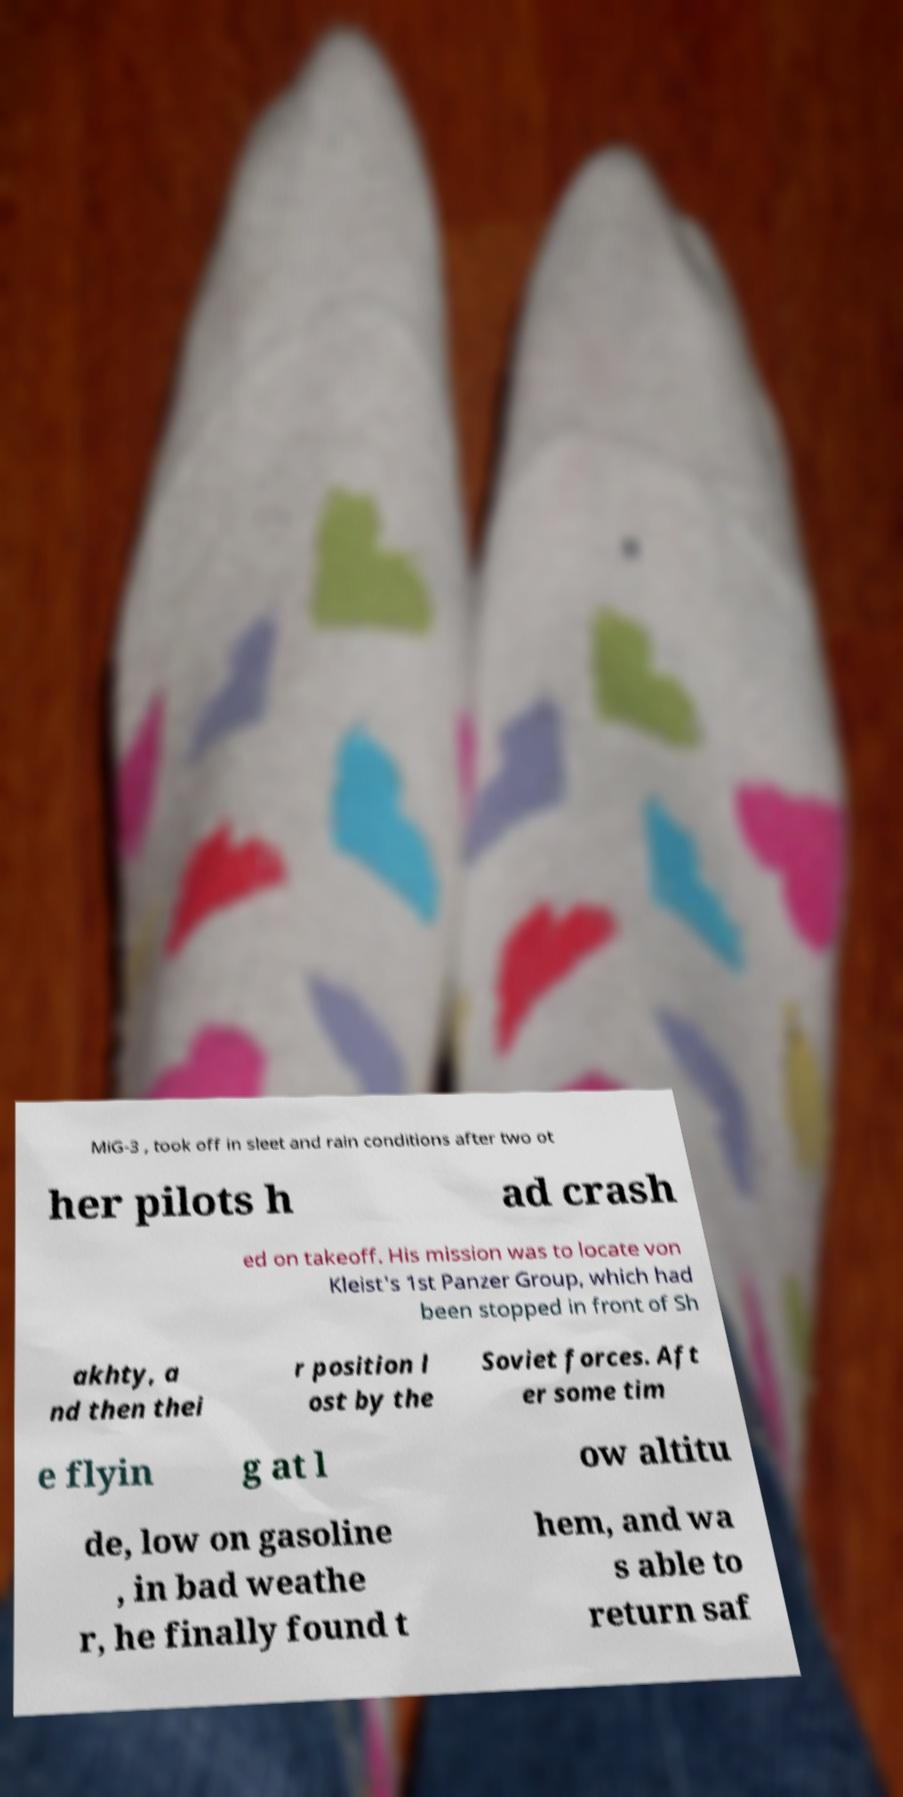Please identify and transcribe the text found in this image. MiG-3 , took off in sleet and rain conditions after two ot her pilots h ad crash ed on takeoff. His mission was to locate von Kleist's 1st Panzer Group, which had been stopped in front of Sh akhty, a nd then thei r position l ost by the Soviet forces. Aft er some tim e flyin g at l ow altitu de, low on gasoline , in bad weathe r, he finally found t hem, and wa s able to return saf 